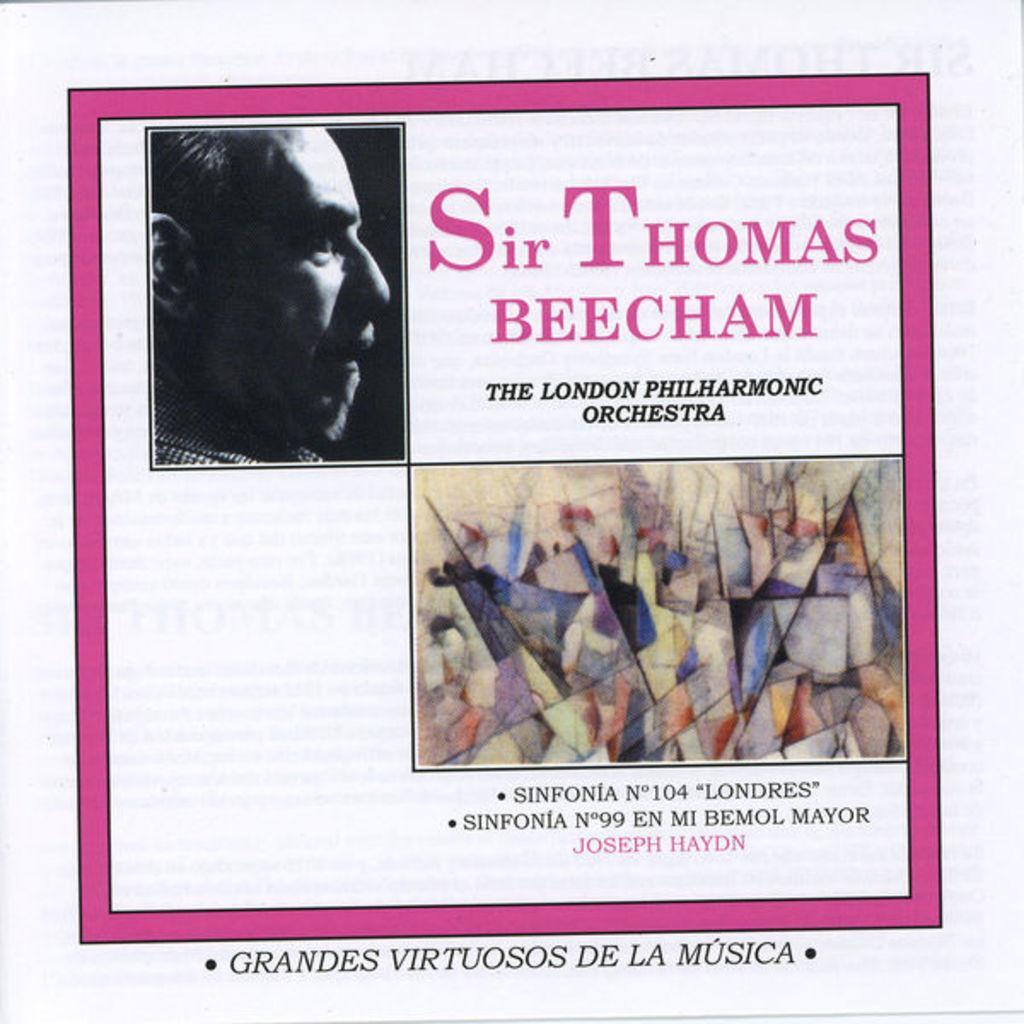Could you give a brief overview of what you see in this image? This image consists of a poster in which there is a picture of a man. To the right, there is a text. The poster border is in pink color. 